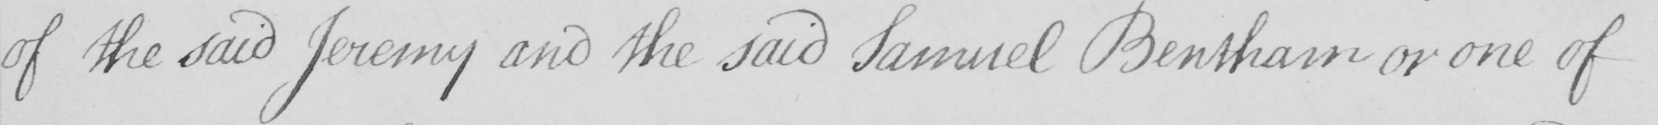Can you read and transcribe this handwriting? of the said Jeremy and the said Samuel Bentham or one of 